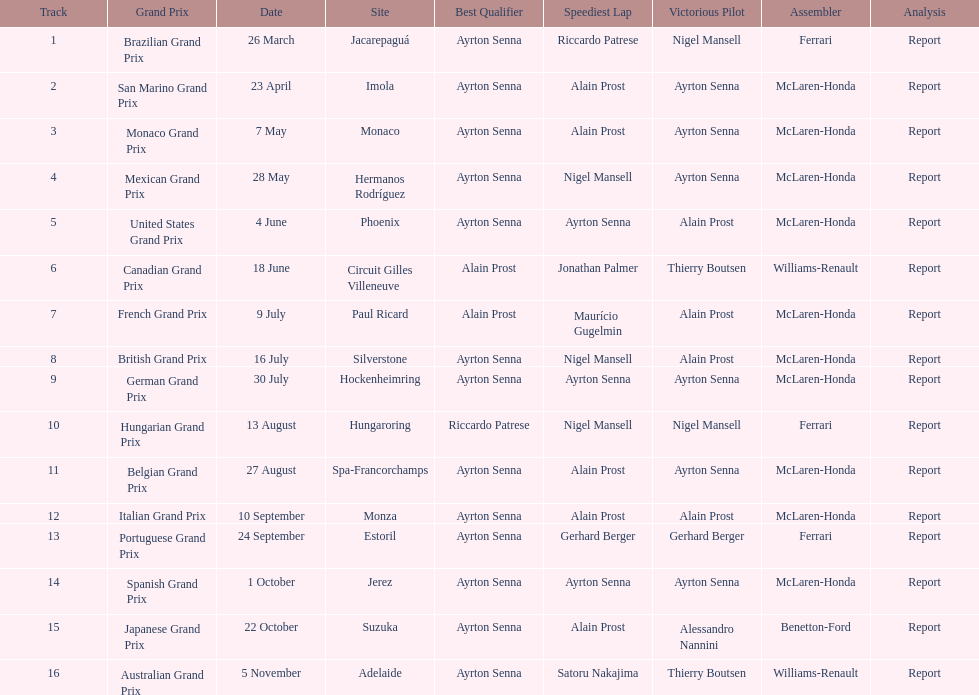How many races occurred before alain prost won a pole position? 5. 